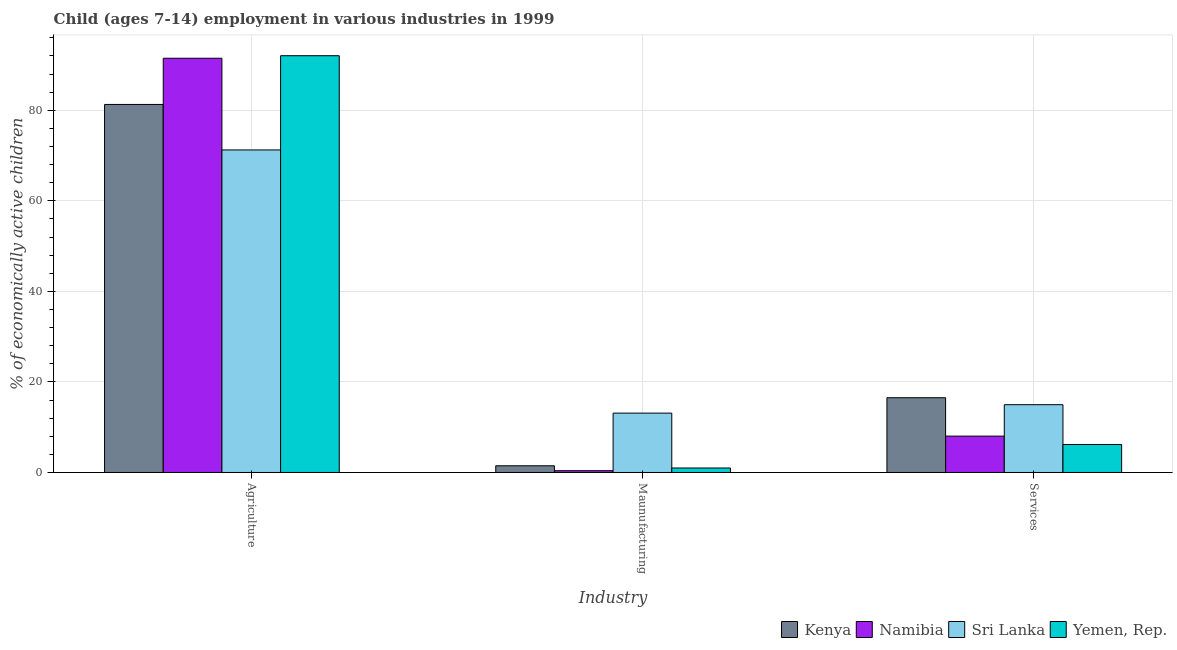Are the number of bars on each tick of the X-axis equal?
Provide a succinct answer. Yes. How many bars are there on the 1st tick from the left?
Provide a short and direct response. 4. How many bars are there on the 2nd tick from the right?
Your answer should be very brief. 4. What is the label of the 3rd group of bars from the left?
Give a very brief answer. Services. What is the percentage of economically active children in services in Kenya?
Offer a terse response. 16.51. Across all countries, what is the maximum percentage of economically active children in manufacturing?
Provide a short and direct response. 13.11. Across all countries, what is the minimum percentage of economically active children in services?
Ensure brevity in your answer.  6.18. In which country was the percentage of economically active children in agriculture maximum?
Provide a short and direct response. Yemen, Rep. In which country was the percentage of economically active children in services minimum?
Provide a succinct answer. Yemen, Rep. What is the total percentage of economically active children in agriculture in the graph?
Give a very brief answer. 336.03. What is the difference between the percentage of economically active children in agriculture in Kenya and that in Sri Lanka?
Your answer should be compact. 10.05. What is the difference between the percentage of economically active children in manufacturing in Yemen, Rep. and the percentage of economically active children in agriculture in Sri Lanka?
Offer a very short reply. -70.24. What is the average percentage of economically active children in manufacturing per country?
Your answer should be compact. 3.99. What is the difference between the percentage of economically active children in manufacturing and percentage of economically active children in agriculture in Namibia?
Your answer should be very brief. -91.09. What is the ratio of the percentage of economically active children in services in Namibia to that in Kenya?
Your response must be concise. 0.49. Is the percentage of economically active children in manufacturing in Sri Lanka less than that in Namibia?
Give a very brief answer. No. What is the difference between the highest and the second highest percentage of economically active children in agriculture?
Your answer should be compact. 0.56. What is the difference between the highest and the lowest percentage of economically active children in services?
Give a very brief answer. 10.33. In how many countries, is the percentage of economically active children in agriculture greater than the average percentage of economically active children in agriculture taken over all countries?
Give a very brief answer. 2. Is the sum of the percentage of economically active children in services in Kenya and Namibia greater than the maximum percentage of economically active children in agriculture across all countries?
Provide a short and direct response. No. What does the 1st bar from the left in Maunufacturing represents?
Your response must be concise. Kenya. What does the 2nd bar from the right in Maunufacturing represents?
Make the answer very short. Sri Lanka. Is it the case that in every country, the sum of the percentage of economically active children in agriculture and percentage of economically active children in manufacturing is greater than the percentage of economically active children in services?
Your response must be concise. Yes. Are all the bars in the graph horizontal?
Offer a terse response. No. How many countries are there in the graph?
Give a very brief answer. 4. Does the graph contain any zero values?
Your answer should be compact. No. How many legend labels are there?
Your response must be concise. 4. What is the title of the graph?
Give a very brief answer. Child (ages 7-14) employment in various industries in 1999. What is the label or title of the X-axis?
Your response must be concise. Industry. What is the label or title of the Y-axis?
Provide a short and direct response. % of economically active children. What is the % of economically active children in Kenya in Agriculture?
Give a very brief answer. 81.28. What is the % of economically active children in Namibia in Agriculture?
Offer a very short reply. 91.48. What is the % of economically active children of Sri Lanka in Agriculture?
Your answer should be compact. 71.23. What is the % of economically active children in Yemen, Rep. in Agriculture?
Ensure brevity in your answer.  92.04. What is the % of economically active children of Kenya in Maunufacturing?
Offer a very short reply. 1.48. What is the % of economically active children of Namibia in Maunufacturing?
Ensure brevity in your answer.  0.39. What is the % of economically active children of Sri Lanka in Maunufacturing?
Your answer should be compact. 13.11. What is the % of economically active children in Kenya in Services?
Your answer should be very brief. 16.51. What is the % of economically active children of Namibia in Services?
Provide a succinct answer. 8.03. What is the % of economically active children of Sri Lanka in Services?
Your answer should be very brief. 14.97. What is the % of economically active children in Yemen, Rep. in Services?
Provide a succinct answer. 6.18. Across all Industry, what is the maximum % of economically active children of Kenya?
Your answer should be very brief. 81.28. Across all Industry, what is the maximum % of economically active children in Namibia?
Offer a terse response. 91.48. Across all Industry, what is the maximum % of economically active children of Sri Lanka?
Offer a terse response. 71.23. Across all Industry, what is the maximum % of economically active children in Yemen, Rep.?
Make the answer very short. 92.04. Across all Industry, what is the minimum % of economically active children in Kenya?
Your response must be concise. 1.48. Across all Industry, what is the minimum % of economically active children of Namibia?
Offer a very short reply. 0.39. Across all Industry, what is the minimum % of economically active children in Sri Lanka?
Ensure brevity in your answer.  13.11. What is the total % of economically active children in Kenya in the graph?
Give a very brief answer. 99.27. What is the total % of economically active children in Namibia in the graph?
Ensure brevity in your answer.  99.9. What is the total % of economically active children of Sri Lanka in the graph?
Ensure brevity in your answer.  99.31. What is the total % of economically active children of Yemen, Rep. in the graph?
Keep it short and to the point. 99.21. What is the difference between the % of economically active children of Kenya in Agriculture and that in Maunufacturing?
Your answer should be compact. 79.8. What is the difference between the % of economically active children in Namibia in Agriculture and that in Maunufacturing?
Offer a terse response. 91.09. What is the difference between the % of economically active children of Sri Lanka in Agriculture and that in Maunufacturing?
Your answer should be compact. 58.12. What is the difference between the % of economically active children of Yemen, Rep. in Agriculture and that in Maunufacturing?
Keep it short and to the point. 91.05. What is the difference between the % of economically active children in Kenya in Agriculture and that in Services?
Ensure brevity in your answer.  64.77. What is the difference between the % of economically active children of Namibia in Agriculture and that in Services?
Your answer should be compact. 83.45. What is the difference between the % of economically active children of Sri Lanka in Agriculture and that in Services?
Offer a very short reply. 56.26. What is the difference between the % of economically active children of Yemen, Rep. in Agriculture and that in Services?
Offer a very short reply. 85.86. What is the difference between the % of economically active children in Kenya in Maunufacturing and that in Services?
Your answer should be very brief. -15.03. What is the difference between the % of economically active children in Namibia in Maunufacturing and that in Services?
Offer a very short reply. -7.64. What is the difference between the % of economically active children in Sri Lanka in Maunufacturing and that in Services?
Make the answer very short. -1.86. What is the difference between the % of economically active children in Yemen, Rep. in Maunufacturing and that in Services?
Your answer should be compact. -5.19. What is the difference between the % of economically active children in Kenya in Agriculture and the % of economically active children in Namibia in Maunufacturing?
Offer a very short reply. 80.89. What is the difference between the % of economically active children in Kenya in Agriculture and the % of economically active children in Sri Lanka in Maunufacturing?
Your answer should be very brief. 68.17. What is the difference between the % of economically active children in Kenya in Agriculture and the % of economically active children in Yemen, Rep. in Maunufacturing?
Offer a terse response. 80.29. What is the difference between the % of economically active children of Namibia in Agriculture and the % of economically active children of Sri Lanka in Maunufacturing?
Provide a short and direct response. 78.37. What is the difference between the % of economically active children in Namibia in Agriculture and the % of economically active children in Yemen, Rep. in Maunufacturing?
Your response must be concise. 90.49. What is the difference between the % of economically active children of Sri Lanka in Agriculture and the % of economically active children of Yemen, Rep. in Maunufacturing?
Make the answer very short. 70.24. What is the difference between the % of economically active children in Kenya in Agriculture and the % of economically active children in Namibia in Services?
Ensure brevity in your answer.  73.25. What is the difference between the % of economically active children of Kenya in Agriculture and the % of economically active children of Sri Lanka in Services?
Provide a succinct answer. 66.31. What is the difference between the % of economically active children of Kenya in Agriculture and the % of economically active children of Yemen, Rep. in Services?
Offer a terse response. 75.1. What is the difference between the % of economically active children in Namibia in Agriculture and the % of economically active children in Sri Lanka in Services?
Give a very brief answer. 76.51. What is the difference between the % of economically active children in Namibia in Agriculture and the % of economically active children in Yemen, Rep. in Services?
Make the answer very short. 85.3. What is the difference between the % of economically active children of Sri Lanka in Agriculture and the % of economically active children of Yemen, Rep. in Services?
Offer a terse response. 65.05. What is the difference between the % of economically active children in Kenya in Maunufacturing and the % of economically active children in Namibia in Services?
Ensure brevity in your answer.  -6.55. What is the difference between the % of economically active children in Kenya in Maunufacturing and the % of economically active children in Sri Lanka in Services?
Keep it short and to the point. -13.49. What is the difference between the % of economically active children in Kenya in Maunufacturing and the % of economically active children in Yemen, Rep. in Services?
Give a very brief answer. -4.7. What is the difference between the % of economically active children in Namibia in Maunufacturing and the % of economically active children in Sri Lanka in Services?
Provide a succinct answer. -14.58. What is the difference between the % of economically active children of Namibia in Maunufacturing and the % of economically active children of Yemen, Rep. in Services?
Give a very brief answer. -5.79. What is the difference between the % of economically active children of Sri Lanka in Maunufacturing and the % of economically active children of Yemen, Rep. in Services?
Offer a very short reply. 6.93. What is the average % of economically active children of Kenya per Industry?
Provide a short and direct response. 33.09. What is the average % of economically active children of Namibia per Industry?
Give a very brief answer. 33.3. What is the average % of economically active children of Sri Lanka per Industry?
Keep it short and to the point. 33.1. What is the average % of economically active children of Yemen, Rep. per Industry?
Offer a very short reply. 33.07. What is the difference between the % of economically active children of Kenya and % of economically active children of Namibia in Agriculture?
Make the answer very short. -10.2. What is the difference between the % of economically active children in Kenya and % of economically active children in Sri Lanka in Agriculture?
Your answer should be compact. 10.05. What is the difference between the % of economically active children of Kenya and % of economically active children of Yemen, Rep. in Agriculture?
Your answer should be very brief. -10.76. What is the difference between the % of economically active children in Namibia and % of economically active children in Sri Lanka in Agriculture?
Offer a terse response. 20.25. What is the difference between the % of economically active children in Namibia and % of economically active children in Yemen, Rep. in Agriculture?
Ensure brevity in your answer.  -0.56. What is the difference between the % of economically active children in Sri Lanka and % of economically active children in Yemen, Rep. in Agriculture?
Make the answer very short. -20.81. What is the difference between the % of economically active children of Kenya and % of economically active children of Namibia in Maunufacturing?
Offer a very short reply. 1.09. What is the difference between the % of economically active children in Kenya and % of economically active children in Sri Lanka in Maunufacturing?
Keep it short and to the point. -11.63. What is the difference between the % of economically active children in Kenya and % of economically active children in Yemen, Rep. in Maunufacturing?
Offer a very short reply. 0.49. What is the difference between the % of economically active children of Namibia and % of economically active children of Sri Lanka in Maunufacturing?
Your answer should be very brief. -12.72. What is the difference between the % of economically active children of Namibia and % of economically active children of Yemen, Rep. in Maunufacturing?
Give a very brief answer. -0.6. What is the difference between the % of economically active children of Sri Lanka and % of economically active children of Yemen, Rep. in Maunufacturing?
Your answer should be very brief. 12.12. What is the difference between the % of economically active children in Kenya and % of economically active children in Namibia in Services?
Offer a very short reply. 8.48. What is the difference between the % of economically active children in Kenya and % of economically active children in Sri Lanka in Services?
Keep it short and to the point. 1.54. What is the difference between the % of economically active children of Kenya and % of economically active children of Yemen, Rep. in Services?
Offer a terse response. 10.33. What is the difference between the % of economically active children in Namibia and % of economically active children in Sri Lanka in Services?
Keep it short and to the point. -6.94. What is the difference between the % of economically active children of Namibia and % of economically active children of Yemen, Rep. in Services?
Your answer should be very brief. 1.85. What is the difference between the % of economically active children of Sri Lanka and % of economically active children of Yemen, Rep. in Services?
Your answer should be very brief. 8.79. What is the ratio of the % of economically active children of Kenya in Agriculture to that in Maunufacturing?
Offer a terse response. 54.84. What is the ratio of the % of economically active children in Namibia in Agriculture to that in Maunufacturing?
Your response must be concise. 234.56. What is the ratio of the % of economically active children of Sri Lanka in Agriculture to that in Maunufacturing?
Your answer should be compact. 5.43. What is the ratio of the % of economically active children of Yemen, Rep. in Agriculture to that in Maunufacturing?
Keep it short and to the point. 92.97. What is the ratio of the % of economically active children of Kenya in Agriculture to that in Services?
Provide a short and direct response. 4.92. What is the ratio of the % of economically active children of Namibia in Agriculture to that in Services?
Provide a succinct answer. 11.39. What is the ratio of the % of economically active children in Sri Lanka in Agriculture to that in Services?
Ensure brevity in your answer.  4.76. What is the ratio of the % of economically active children in Yemen, Rep. in Agriculture to that in Services?
Your answer should be very brief. 14.89. What is the ratio of the % of economically active children of Kenya in Maunufacturing to that in Services?
Keep it short and to the point. 0.09. What is the ratio of the % of economically active children of Namibia in Maunufacturing to that in Services?
Keep it short and to the point. 0.05. What is the ratio of the % of economically active children of Sri Lanka in Maunufacturing to that in Services?
Offer a terse response. 0.88. What is the ratio of the % of economically active children in Yemen, Rep. in Maunufacturing to that in Services?
Provide a short and direct response. 0.16. What is the difference between the highest and the second highest % of economically active children in Kenya?
Provide a short and direct response. 64.77. What is the difference between the highest and the second highest % of economically active children in Namibia?
Keep it short and to the point. 83.45. What is the difference between the highest and the second highest % of economically active children of Sri Lanka?
Provide a short and direct response. 56.26. What is the difference between the highest and the second highest % of economically active children of Yemen, Rep.?
Give a very brief answer. 85.86. What is the difference between the highest and the lowest % of economically active children in Kenya?
Your answer should be very brief. 79.8. What is the difference between the highest and the lowest % of economically active children in Namibia?
Offer a very short reply. 91.09. What is the difference between the highest and the lowest % of economically active children of Sri Lanka?
Offer a very short reply. 58.12. What is the difference between the highest and the lowest % of economically active children in Yemen, Rep.?
Your answer should be very brief. 91.05. 